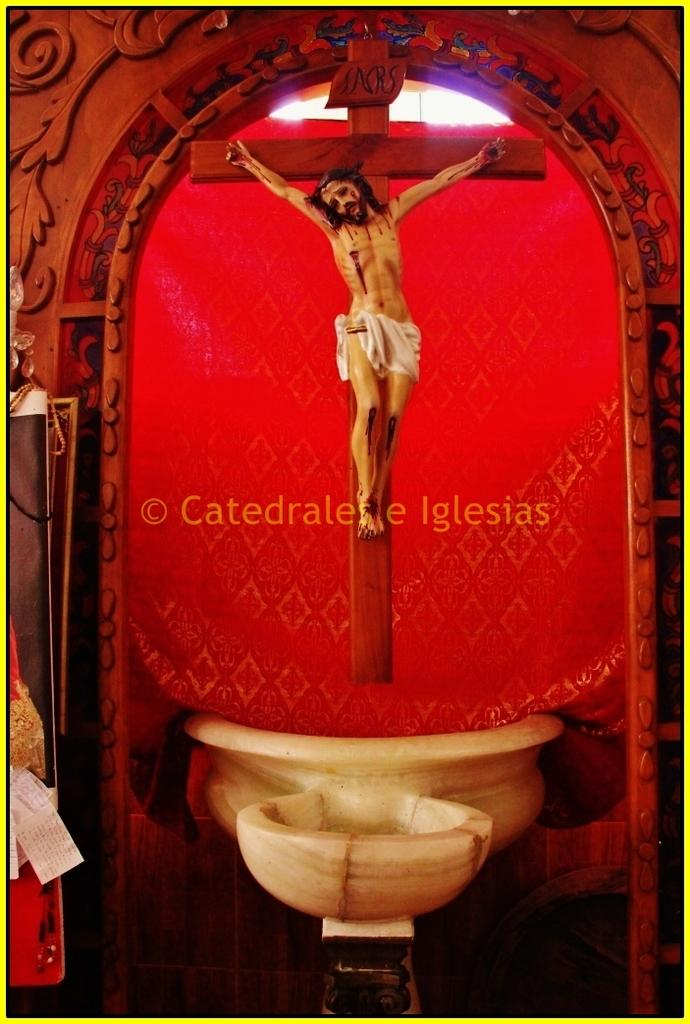What is the main subject of the image? The main subject of the image is a statue. Where is the statue located? The statue is on a cross sign. What other objects can be seen in the image? There is a wooden carving and some red color cloth in the image. Is there any text present in the image? Yes, there is some text at the center of the image. What type of fish can be seen fighting with the statue in the image? There are no fish or fighting depicted in the image; it features a statue on a cross sign with a wooden carving, red color cloth, and some text. 